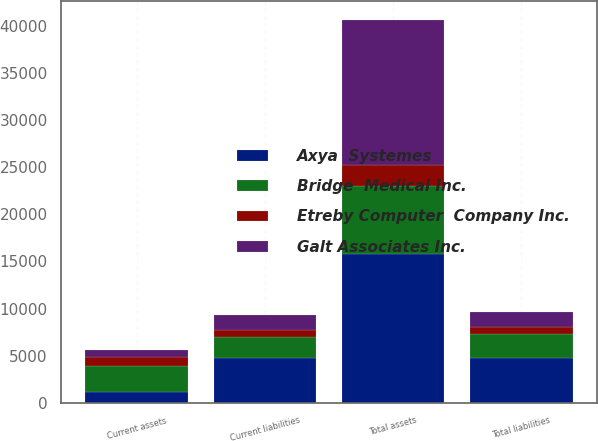<chart> <loc_0><loc_0><loc_500><loc_500><stacked_bar_chart><ecel><fcel>Current assets<fcel>Total assets<fcel>Current liabilities<fcel>Total liabilities<nl><fcel>Etreby Computer  Company Inc.<fcel>1002<fcel>2244<fcel>748<fcel>748<nl><fcel>Galt Associates Inc.<fcel>751<fcel>15372<fcel>1606<fcel>1606<nl><fcel>Axya  Systemes<fcel>1172<fcel>15802<fcel>4748<fcel>4783<nl><fcel>Bridge  Medical Inc.<fcel>2680<fcel>7209<fcel>2244<fcel>2483<nl></chart> 